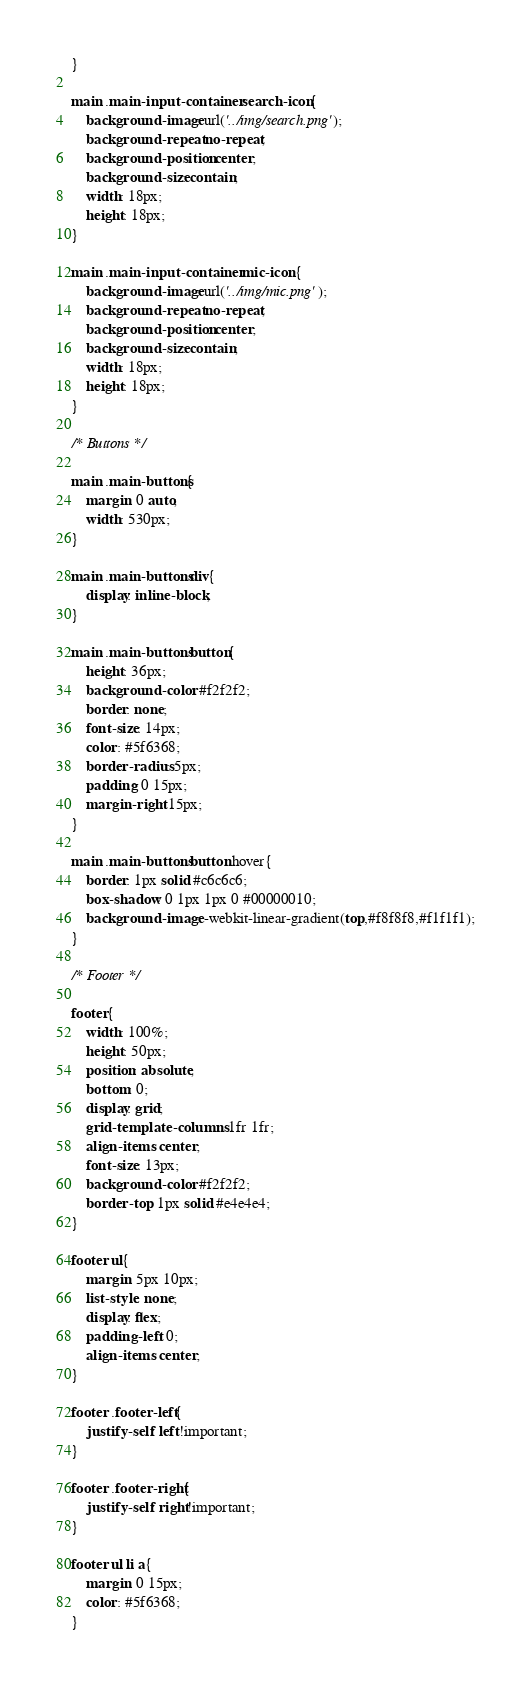<code> <loc_0><loc_0><loc_500><loc_500><_CSS_>}

main .main-input-container .search-icon{
	background-image: url('../img/search.png');
	background-repeat: no-repeat;
	background-position: center;
	background-size: contain;
	width: 18px;
	height: 18px;
}

main .main-input-container .mic-icon{
	background-image: url('../img/mic.png');
	background-repeat: no-repeat;
	background-position: center;
	background-size: contain;
	width: 18px;
	height: 18px;
}

/* Buttons */

main .main-buttons{
	margin: 0 auto;
	width: 530px;
}

main .main-buttons div{
	display: inline-block;
}

main .main-buttons button{
	height: 36px;
	background-color: #f2f2f2;
	border: none;
	font-size: 14px;
	color: #5f6368;
	border-radius: 5px;
	padding: 0 15px;
	margin-right: 15px; 
}

main .main-buttons button:hover{
	border: 1px solid #c6c6c6;
	box-shadow: 0 1px 1px 0 #00000010;
	background-image: -webkit-linear-gradient(top,#f8f8f8,#f1f1f1);
}

/* Footer */

footer{
	width: 100%;
	height: 50px;
	position: absolute;
	bottom: 0;
	display: grid;
	grid-template-columns: 1fr 1fr;
	align-items: center;
	font-size: 13px;
	background-color: #f2f2f2;
	border-top: 1px solid #e4e4e4;
}

footer ul{
	margin: 5px 10px;
	list-style: none;
	display: flex;
	padding-left: 0;
	align-items: center;
}

footer .footer-left{
	justify-self: left!important;
}

footer .footer-right{
	justify-self: right!important;
}

footer ul li a{
	margin: 0 15px;
	color: #5f6368; 	
}
</code> 